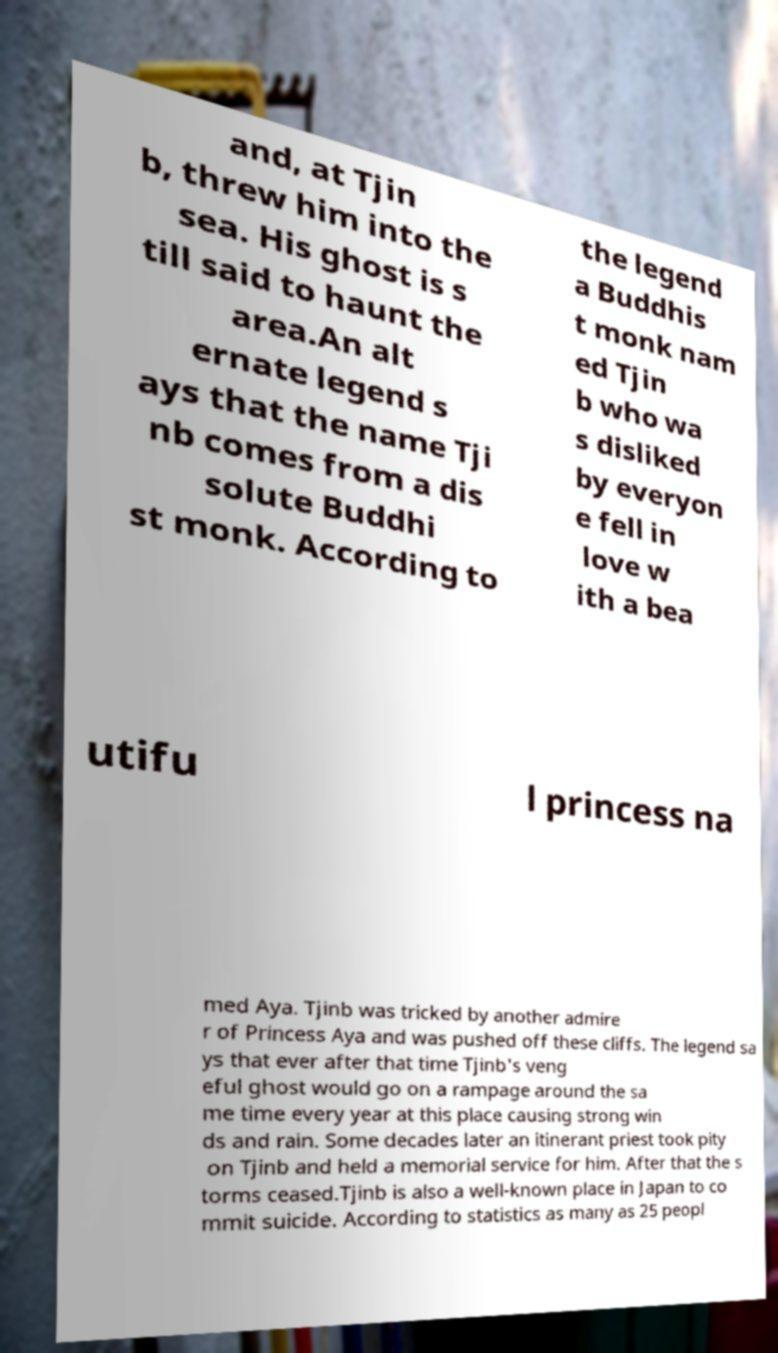What messages or text are displayed in this image? I need them in a readable, typed format. and, at Tjin b, threw him into the sea. His ghost is s till said to haunt the area.An alt ernate legend s ays that the name Tji nb comes from a dis solute Buddhi st monk. According to the legend a Buddhis t monk nam ed Tjin b who wa s disliked by everyon e fell in love w ith a bea utifu l princess na med Aya. Tjinb was tricked by another admire r of Princess Aya and was pushed off these cliffs. The legend sa ys that ever after that time Tjinb's veng eful ghost would go on a rampage around the sa me time every year at this place causing strong win ds and rain. Some decades later an itinerant priest took pity on Tjinb and held a memorial service for him. After that the s torms ceased.Tjinb is also a well-known place in Japan to co mmit suicide. According to statistics as many as 25 peopl 